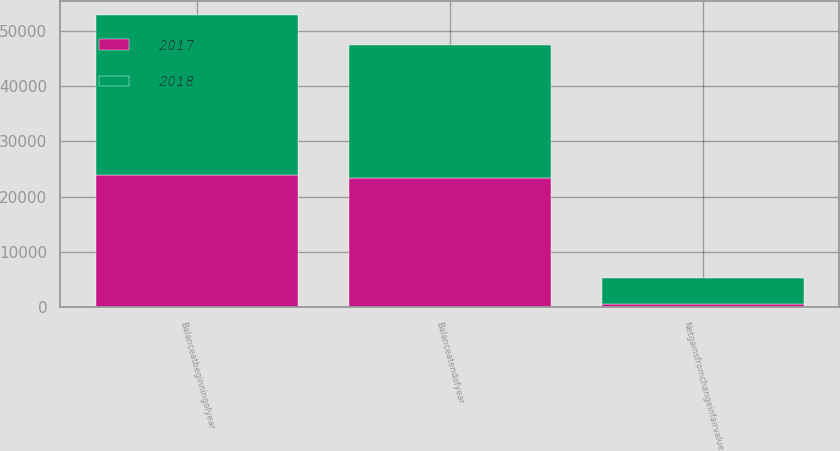<chart> <loc_0><loc_0><loc_500><loc_500><stacked_bar_chart><ecel><fcel>Balanceatbeginningofyear<fcel>Netgainsfromchangeinfairvalue<fcel>Balanceatendofyear<nl><fcel>2017<fcel>23980<fcel>540<fcel>23440<nl><fcel>2018<fcel>28770<fcel>4790<fcel>23980<nl></chart> 